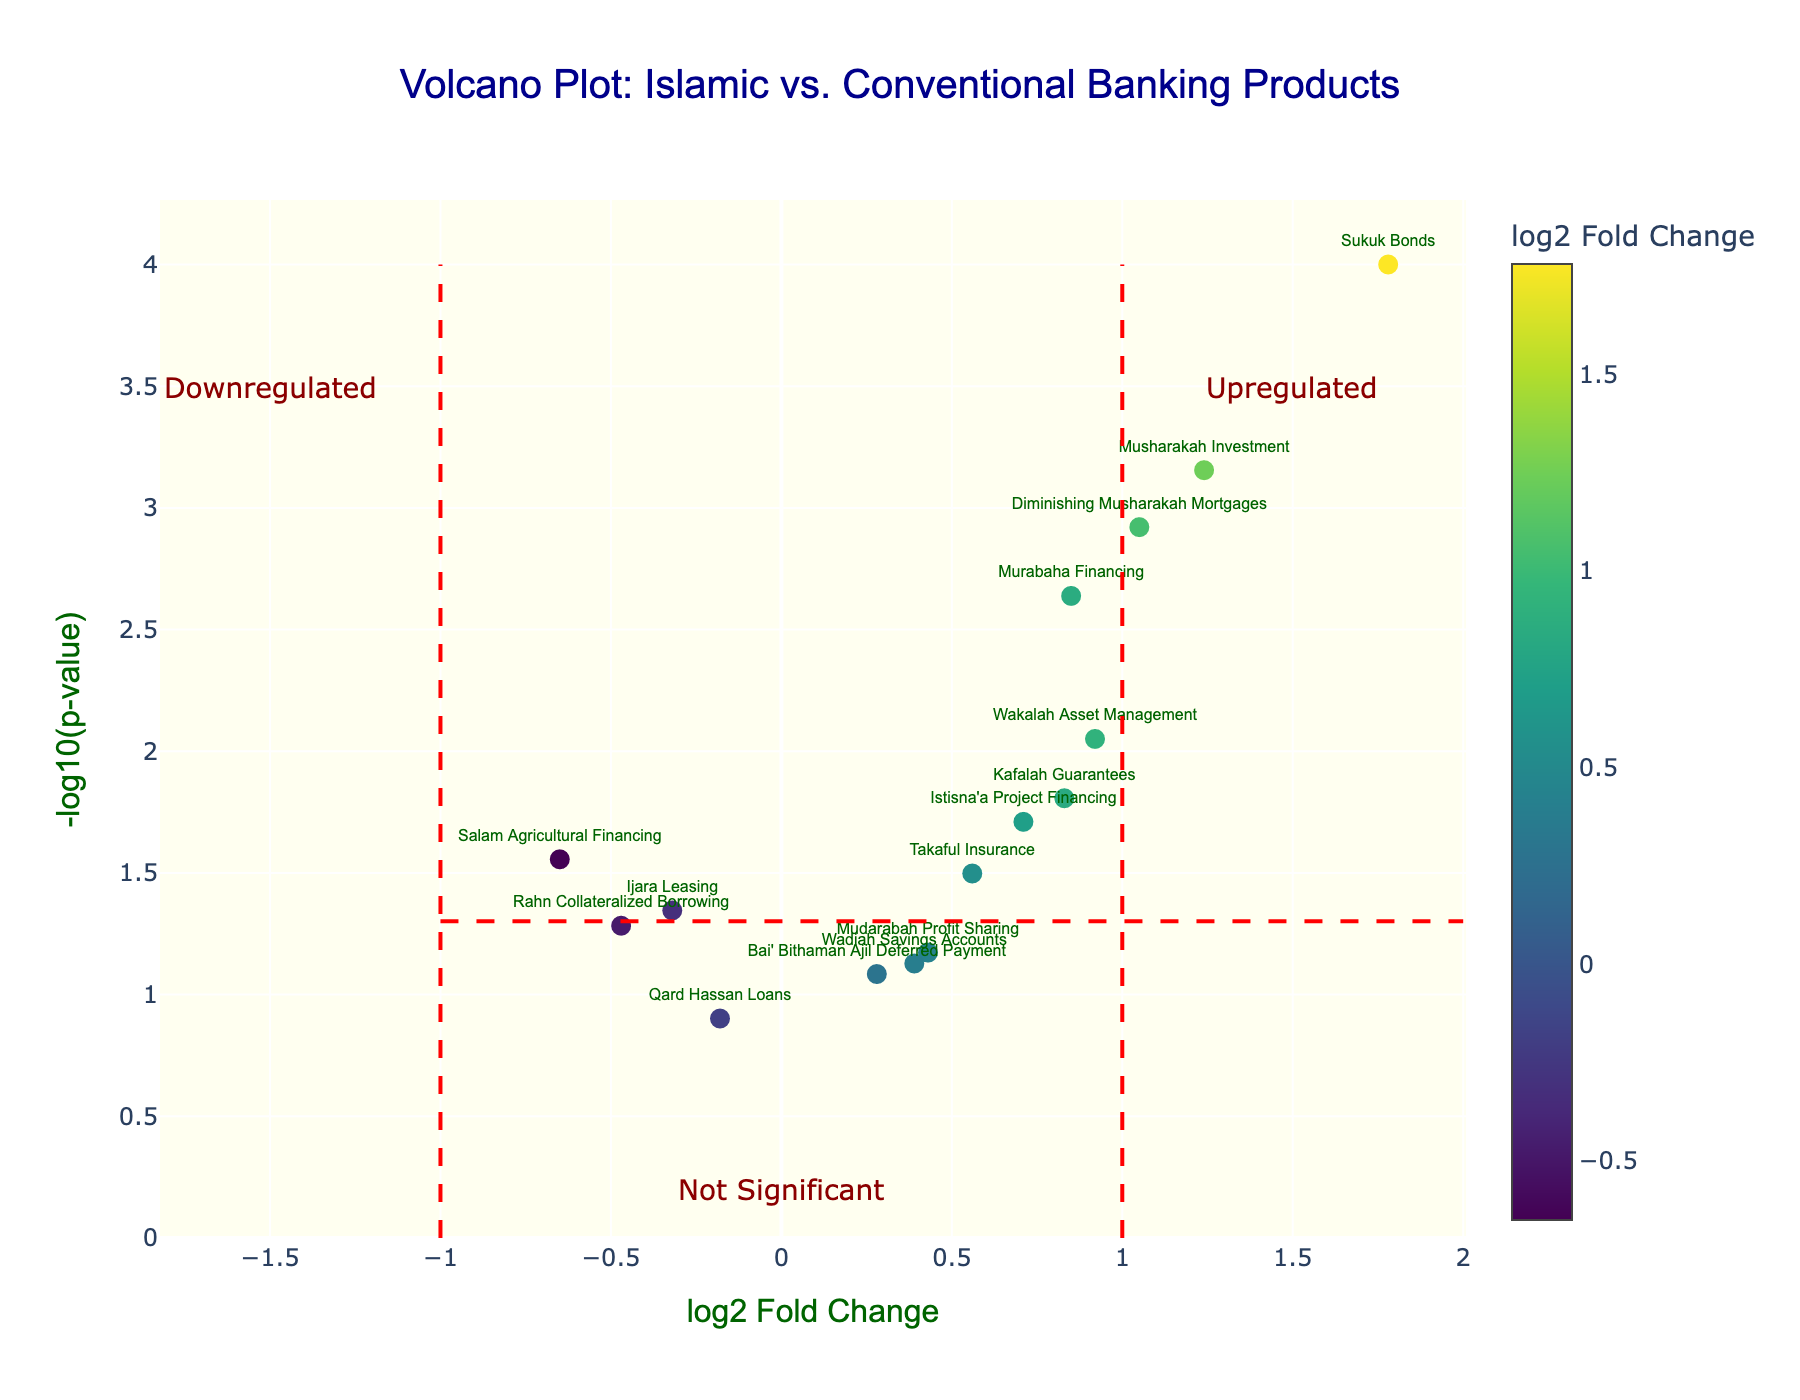How many Islamic banking products have a log2 fold change greater than 1? To find out how many products have a log2 fold change greater than 1, locate the corresponding x-axis value on the volcano plot. Identify the points that lie to the right of the red line at x=1. Count these data points.
Answer: 4 Which product has the highest log2 fold change, and what is its p-value? Locate the point farthest to the right on the x-axis, which represents the highest log2 fold change. Hover over this point on the figure for its details.
Answer: Sukuk Bonds, 0.0001 What is the significance threshold for the p-value in this plot, and how is it visually represented? The significance threshold for the p-value is represented by the horizontal dashed red line. This line is placed at -log10(0.05).
Answer: 0.05, horizontal dashed red line How many products are depicted as "Not Significant" in the plot? Products are classified as "Not Significant" if they fall below the significance threshold line on the y-axis and between the red lines at x=-1 and x=1 on the x-axis. Count these points.
Answer: 4 Which product has the lowest -log10(p-value), and what is its log2 fold change? To find the product with the lowest -log10(p-value), locate the point lowest on the y-axis. Hover over the point to get its details.
Answer: Qard Hassan Loans, -0.18 Which Islamic banking product shows the most significant downregulation, and what are its log2 fold change and p-value? Identify the point farthest to the left on the x-axis but below the significance threshold line. The furthest to the left represents the most significant downregulation. Hover over the corresponding point for details.
Answer: Salam Agricultural Financing, -0.65 Among the products with positive log2 fold change, which one has the second-highest -log10(p-value)? First, focus on products with positive log2 fold change values. Identify the second-highest -log10(p-value) among these points by comparing their heights on the y-axis. Hover over the points for details.
Answer: Wakalah Asset Management Compare Musharakah Investment and Kafalah Guarantees. Which one is more significant in terms of p-value and by what factor is its p-value smaller? Compare the -log10(p-value) of both Musharakah Investment and Kafalah Guarantees. The higher value on the y-axis indicates a smaller p-value. Calculate the fold difference based on p-values. Musharakah Investment has a -log10(p-value) of approximately 3.15, and Kafalah Guarantees has approximately 1.81. Therefore, the factor is 10^(1.81-3.15).
Answer: Musharakah Investment, ~22 times How many products are classified as upregulated and have a p-value less than 0.01? Upregulated products lie to the right of the x=1 line. To determine how many of these have a p-value less than 0.01, look for points above -log10(0.01) on the y-axis. Count these points.
Answer: 4 